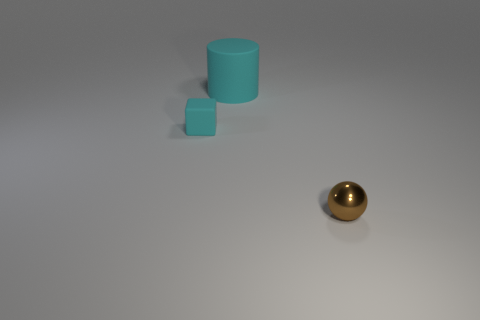Does the rubber cube have the same color as the big matte object?
Keep it short and to the point. Yes. There is a tiny rubber thing that is the same color as the large matte cylinder; what is its shape?
Keep it short and to the point. Cube. There is a large thing behind the cyan cube; what number of shiny balls are in front of it?
Make the answer very short. 1. How many other small brown balls are the same material as the tiny brown sphere?
Your answer should be very brief. 0. There is a cylinder; are there any cyan cubes to the right of it?
Ensure brevity in your answer.  No. What is the color of the other thing that is the same size as the metallic object?
Offer a very short reply. Cyan. What number of things are either things behind the small brown sphere or big cyan cylinders?
Keep it short and to the point. 2. What is the size of the object that is both in front of the cylinder and to the left of the tiny brown metal thing?
Ensure brevity in your answer.  Small. There is a rubber cube that is the same color as the large cylinder; what size is it?
Keep it short and to the point. Small. How many other things are the same size as the cyan cylinder?
Your answer should be very brief. 0. 